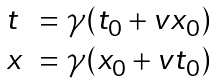<formula> <loc_0><loc_0><loc_500><loc_500>\begin{array} { l l } t & = \gamma ( t _ { 0 } + v x _ { 0 } ) \\ x & = \gamma ( x _ { 0 } + v t _ { 0 } ) \end{array}</formula> 